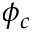<formula> <loc_0><loc_0><loc_500><loc_500>\phi _ { c }</formula> 